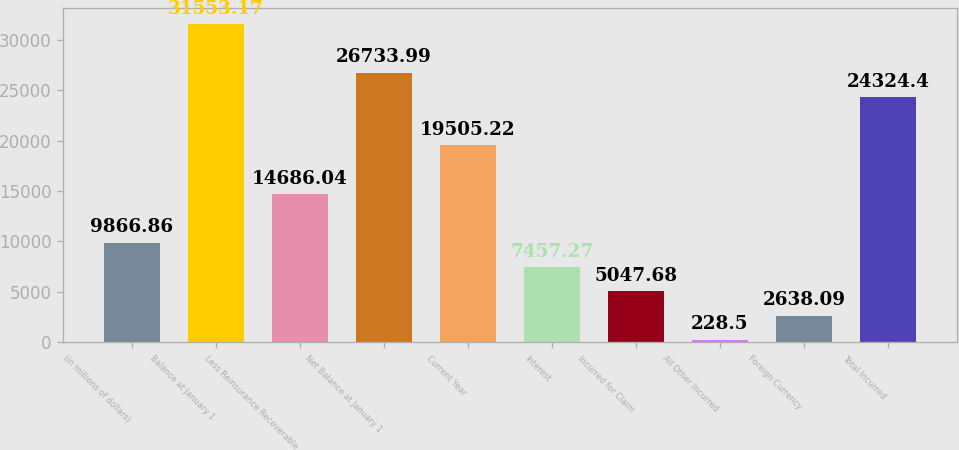<chart> <loc_0><loc_0><loc_500><loc_500><bar_chart><fcel>(in millions of dollars)<fcel>Balance at January 1<fcel>Less Reinsurance Recoverable<fcel>Net Balance at January 1<fcel>Current Year<fcel>Interest<fcel>Incurred for Claim<fcel>All Other Incurred<fcel>Foreign Currency<fcel>Total Incurred<nl><fcel>9866.86<fcel>31553.2<fcel>14686<fcel>26734<fcel>19505.2<fcel>7457.27<fcel>5047.68<fcel>228.5<fcel>2638.09<fcel>24324.4<nl></chart> 